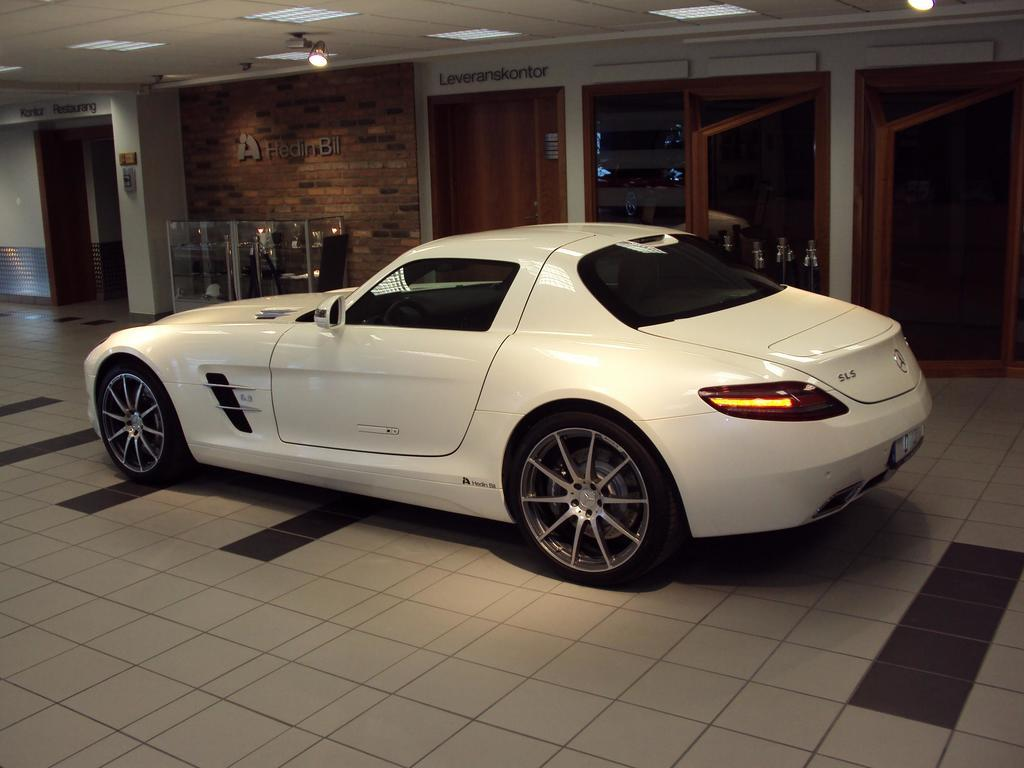What is placed on the floor in the image? There is a car on the floor in the image. What can be seen on the wall in the image? There is a wall with text and doors in the image. What is located in front of the wall in the image? There is an object in front of the wall in the image. What is present on the ceiling in the image? There are lights on the ceiling in the image. What type of insurance is required for the steel steam engine in the image? There is no steel steam engine present in the image, nor is there any mention of insurance. 